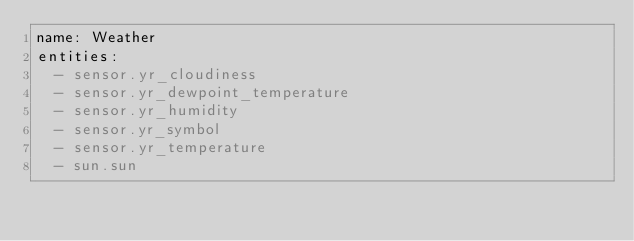<code> <loc_0><loc_0><loc_500><loc_500><_YAML_>name: Weather
entities:
  - sensor.yr_cloudiness
  - sensor.yr_dewpoint_temperature
  - sensor.yr_humidity
  - sensor.yr_symbol
  - sensor.yr_temperature
  - sun.sun
</code> 